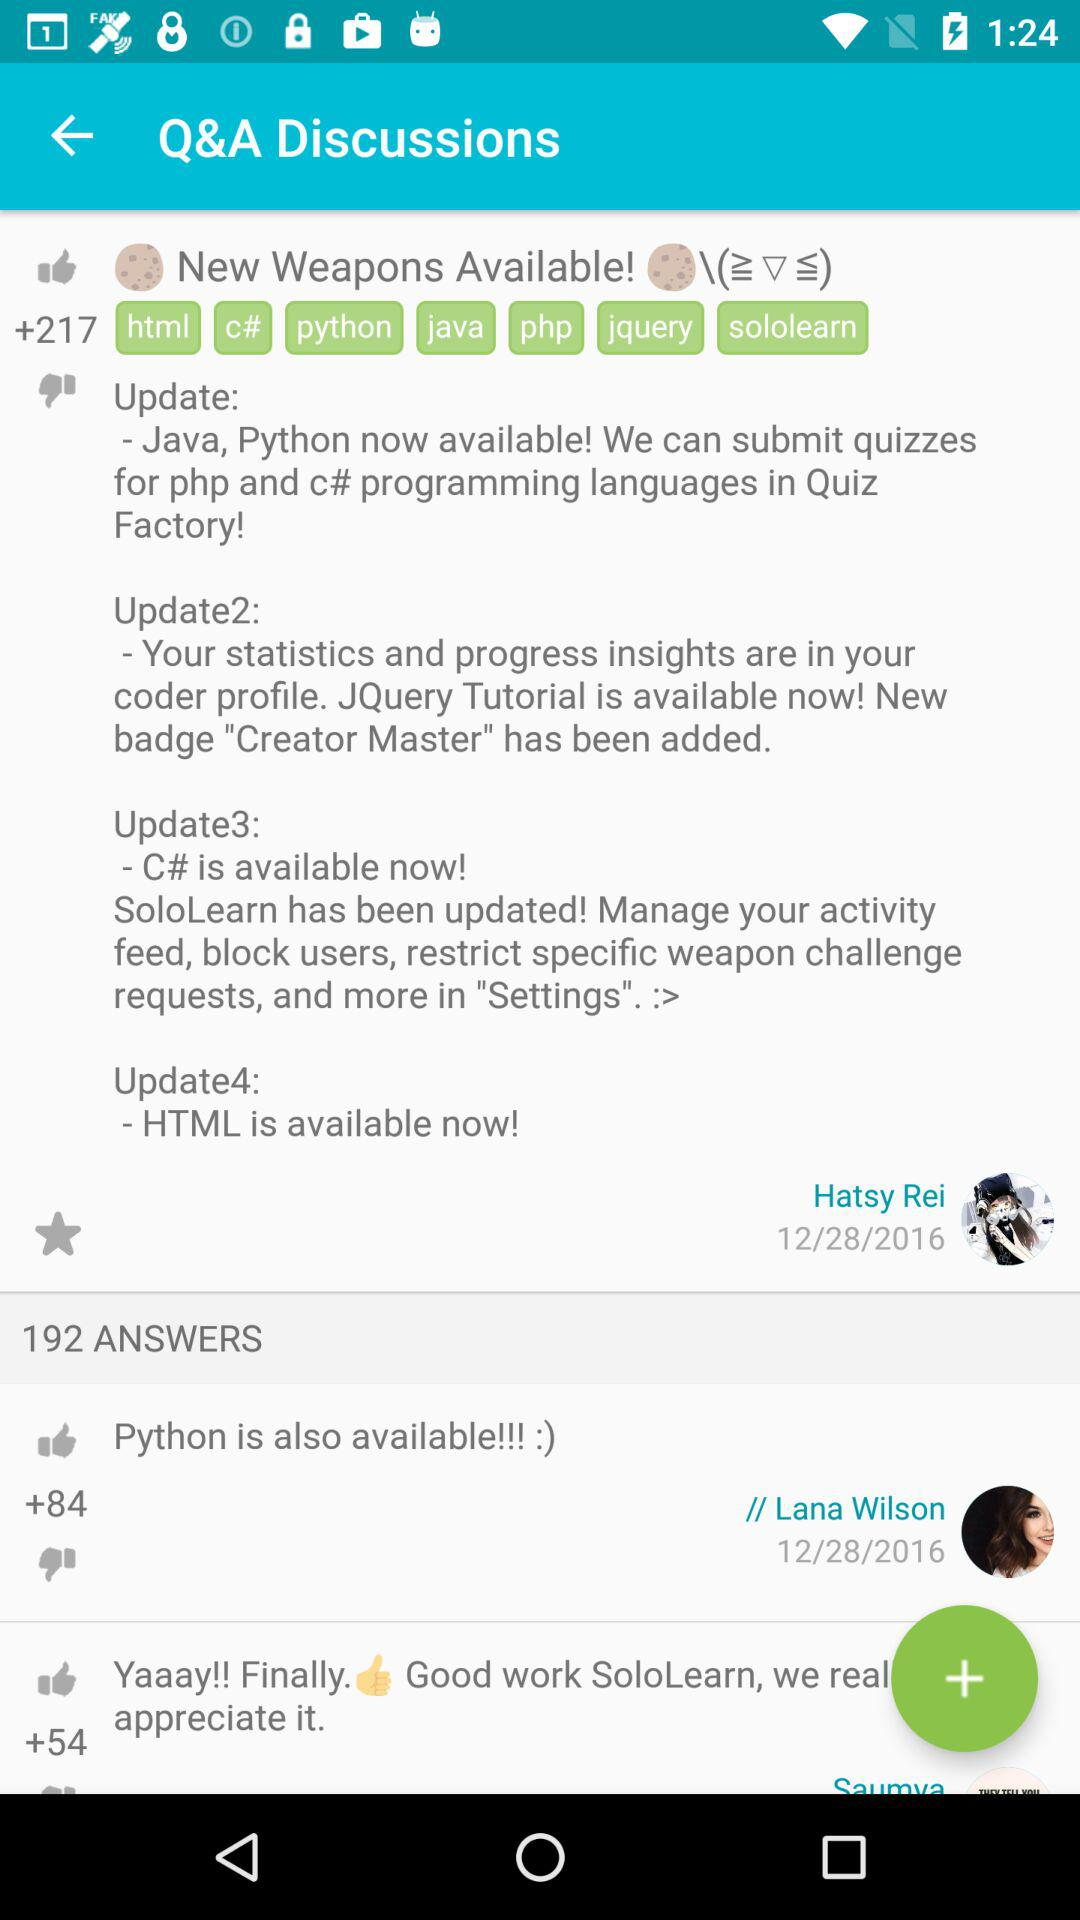On what date did Lana Wilson post an answer? Lana Wilson posted an answer on December 28, 2016. 